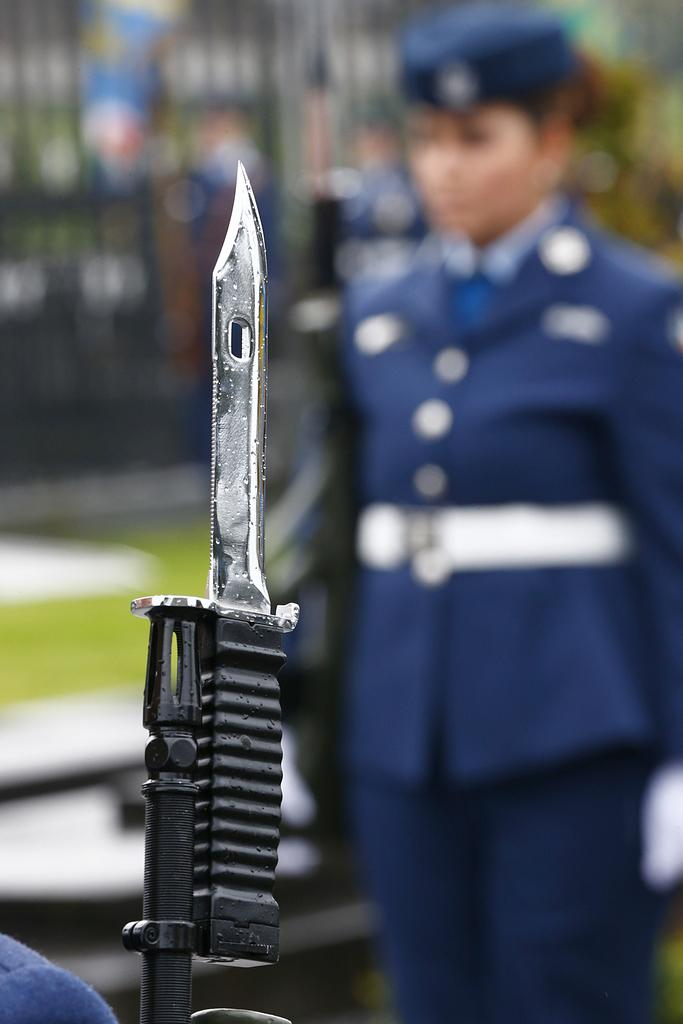What is the main object in the foreground of the image? There is a knife of a gun in the foreground of the image. What color is the object in the foreground? There is a blue color object in the foreground of the image. How would you describe the background of the image? The background of the image is blurred. Can you identify any people in the background of the image? Yes, there is a soldier in the background of the image. What other elements can be seen in the background of the image? There is railing and greenery in the background of the image. What time does the clock in the image show? There is no clock present in the image. What advice does the writer in the image give to the son? There is no writer or son present in the image. 